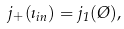<formula> <loc_0><loc_0><loc_500><loc_500>j _ { + } ( \zeta _ { i n } ) = j _ { 1 } ( \chi ) ,</formula> 